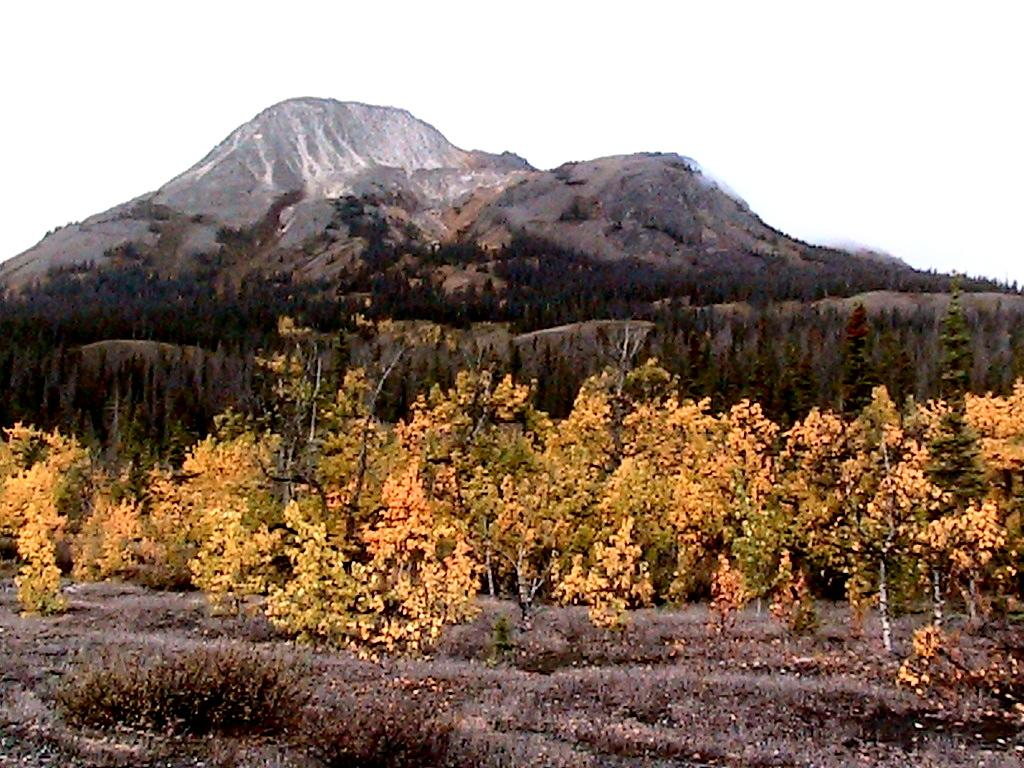What type of vegetation can be seen in the image? There are trees in the image. What colors are the trees in the image? The trees have yellow and green colors. What can be seen in the distance behind the trees? There are mountains in the background of the image. What color is the sky in the background of the image? The sky is blue in the background of the image. How many snakes are slithering through the trees in the image? There are no snakes present in the image; it features trees with yellow and green colors, mountains in the background, and a blue sky. 